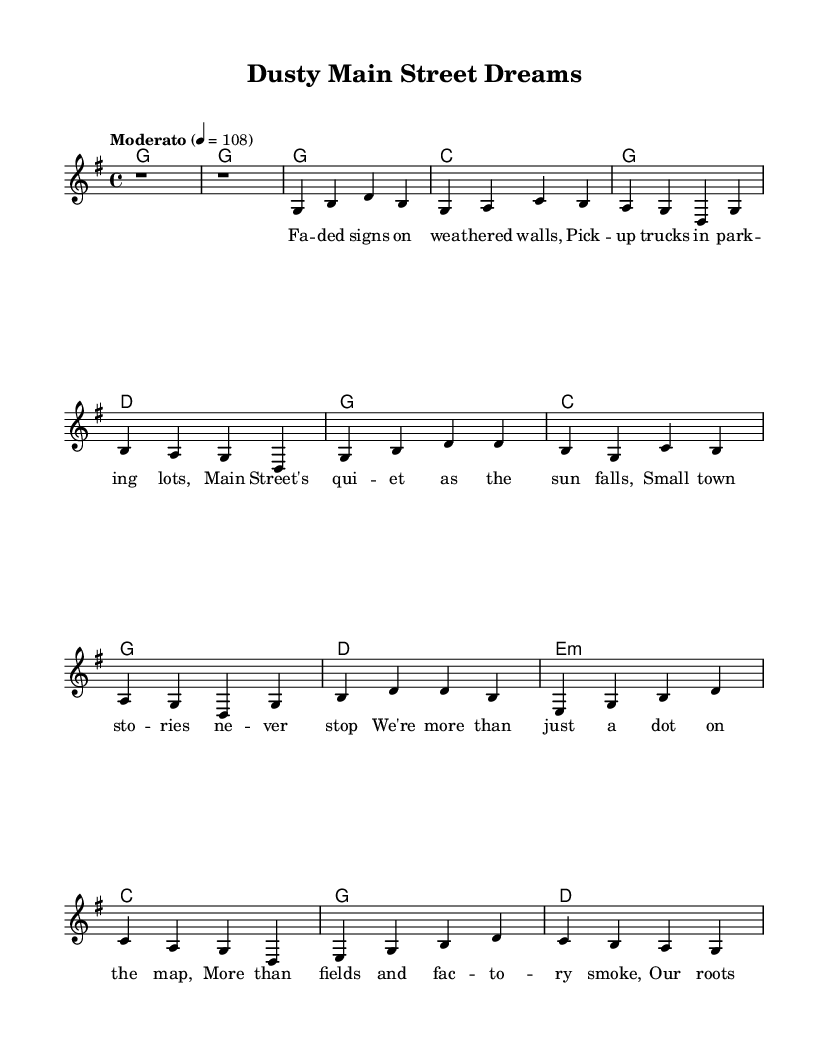What is the key signature of this music? The key signature is G major, which has one sharp (F#). It’s visible at the beginning of the staff where the key signature is indicated.
Answer: G major What is the time signature of this music? The time signature is 4/4, meaning there are four beats in a measure and the quarter note gets one beat. This is typically indicated at the start of the music.
Answer: 4/4 What is the tempo marking for this piece? The tempo marking is "Moderato" at a speed of 108 beats per minute. This is commonly placed at the beginning of the score to indicate the intended speed of the piece.
Answer: Moderato 108 How many measures are in the chorus section? The chorus consists of 4 measures, as you can count from the music notation for that section, which has 4 groupings of notes.
Answer: 4 What is the main lyrical theme of the song? The main lyrical theme revolves around small-town identity, emphasizing the depth of roots and communal stories that go beyond mere location. This can be inferred from the lyrics and their emotional content.
Answer: Small-town identity What chords are used in the bridge section? The chords used in the bridge are E minor, C, G, and D. These chords are clearly notated in the chord section alongside the corresponding melody notes.
Answer: E minor, C, G, D What instrument is typically represented in the staff for lead melody? The instrument represented in the staff for the lead melody is a voice, as indicated by the label "lead" for the voice section. This suggests the vocal line is the primary focus.
Answer: Voice 